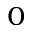<formula> <loc_0><loc_0><loc_500><loc_500>_ { 0 }</formula> 